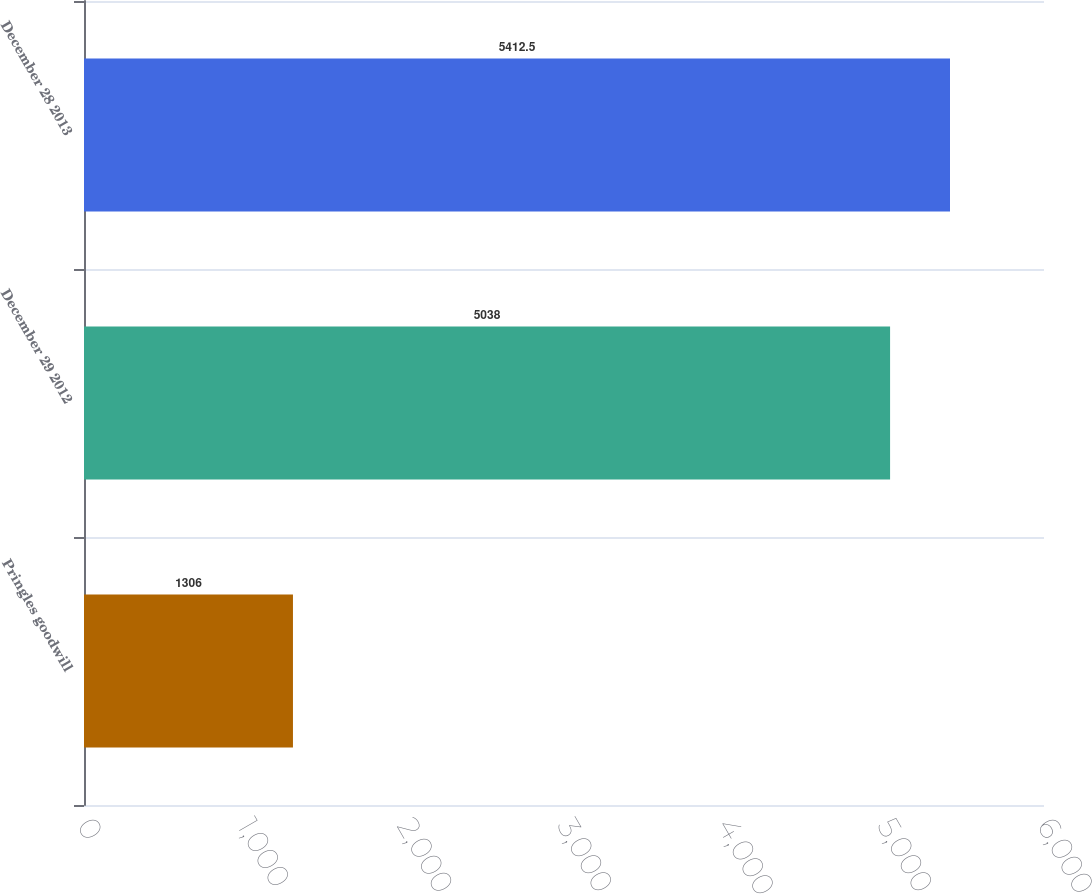Convert chart. <chart><loc_0><loc_0><loc_500><loc_500><bar_chart><fcel>Pringles goodwill<fcel>December 29 2012<fcel>December 28 2013<nl><fcel>1306<fcel>5038<fcel>5412.5<nl></chart> 